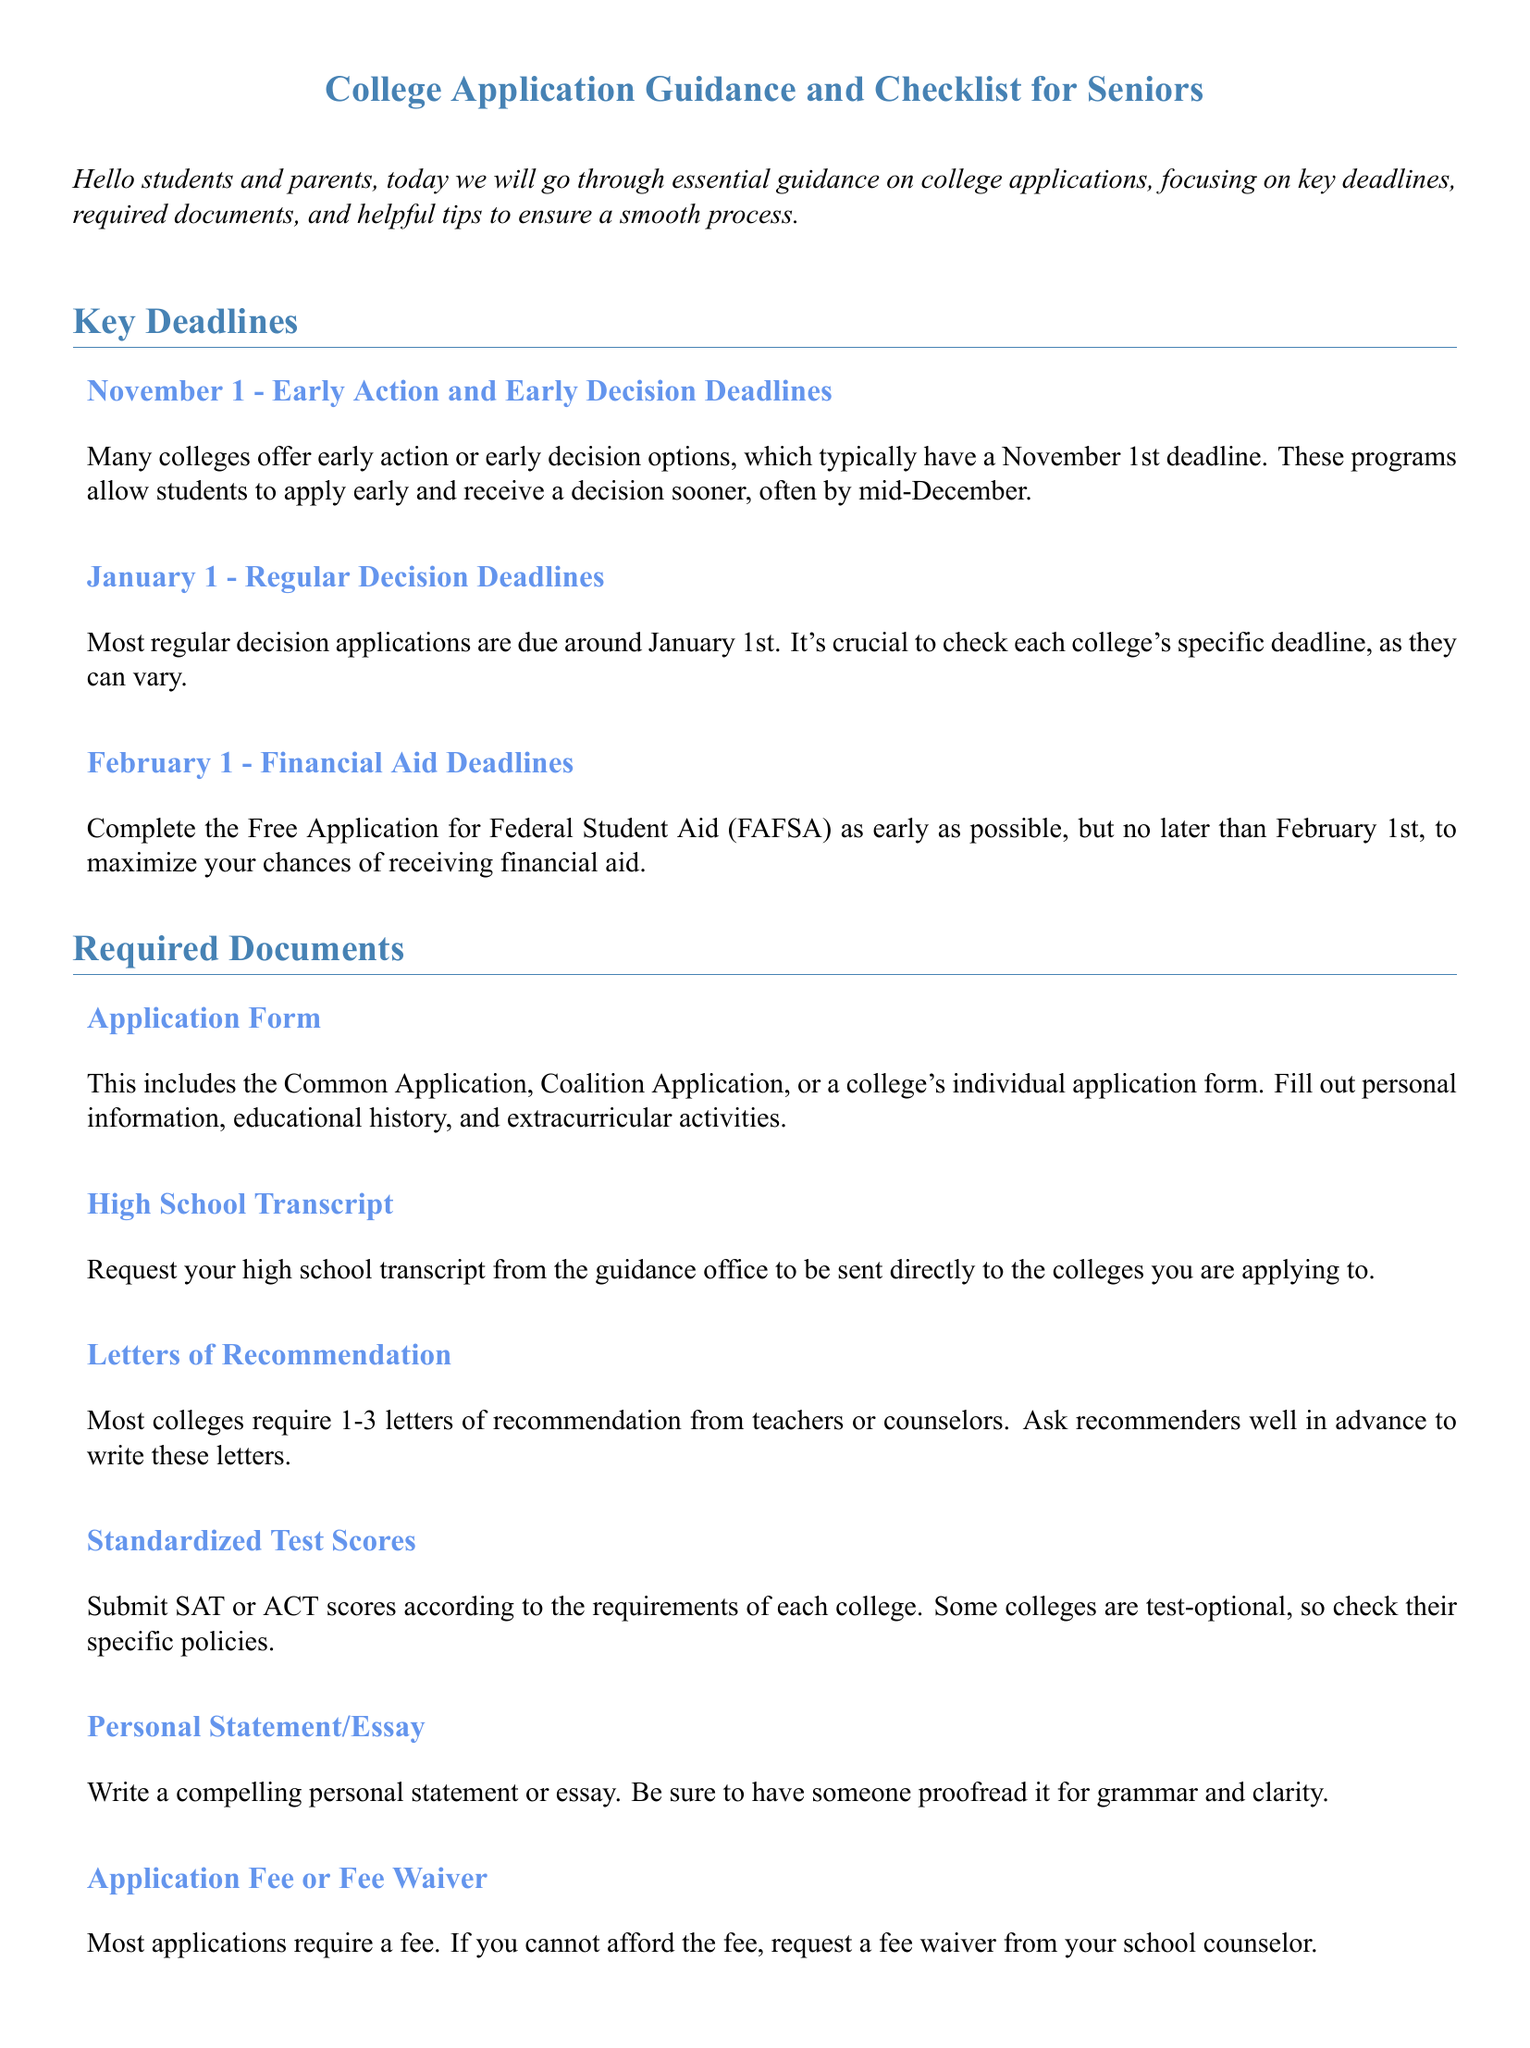What is the early action and early decision deadline? The early action and early decision deadline is specifically stated as November 1.
Answer: November 1 When are the regular decision applications due? The document indicates that most regular decision applications are due around January 1.
Answer: January 1 What is the deadline to complete the FAFSA? The document mentions that the FAFSA must be completed no later than February 1.
Answer: February 1 How many letters of recommendation are typically required? The required number of letters of recommendation is between 1 to 3, as mentioned in the document.
Answer: 1-3 What type of application forms are mentioned? The document refers to the Common Application, Coalition Application, or a college's individual application form as the types of application forms.
Answer: Common Application, Coalition Application, individual application form What is an important step to ensure applications are error-free? The document emphasizes the importance of proofreading everything to ensure there are no errors.
Answer: Proofread everything What is one way to stay organized during the application process? The document suggests creating a checklist of all application requirements and deadlines.
Answer: Create a checklist What should students do to check if their applications are complete? The document advises students to confirm that colleges received all parts of their application, including transcripts.
Answer: Confirm receipt of all application parts What is a helpful tip for managing stress during the application process? The document encourages students to take care of themselves, including taking breaks and exercising.
Answer: Take care of yourself 